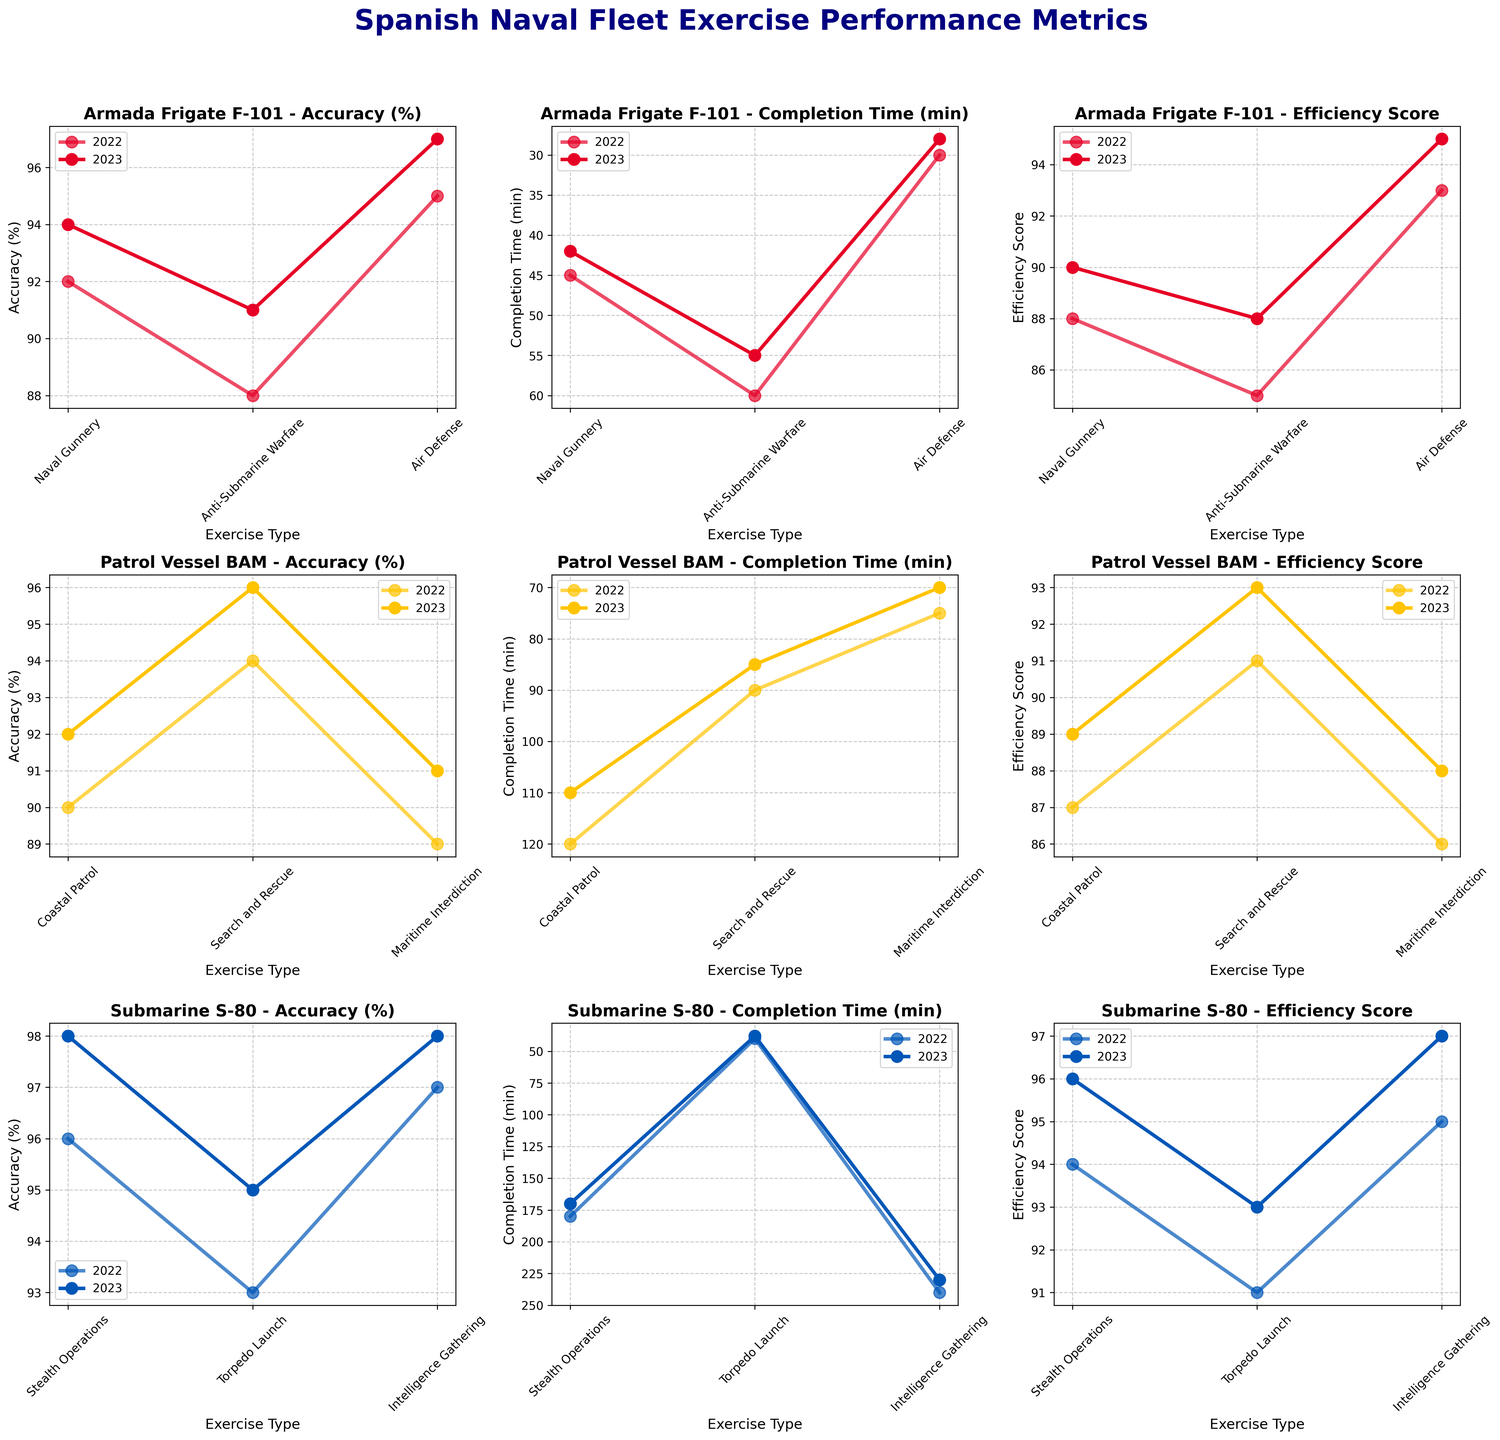What is the overall title of the figure? The figure has a main title written at the top that summarizes what the figure is displaying. This is usually the largest and boldest text.
Answer: Spanish Naval Fleet Exercise Performance Metrics Which unit performed the "Air Defense" exercise in 2023? By looking at the subplot titles and the corresponding exercise types for the year 2023, the unit can be identified. The "Air Defense" exercise type falls under the "Armada Frigate F-101" unit in 2023 as indicated on the relevant subplot.
Answer: Armada Frigate F-101 How did the "Completion Time" for the "Anti-Submarine Warfare" exercise change from 2022 to 2023 for the Armada Frigate F-101? Locate the subplot related to "Armada Frigate F-101" - "Completion Time (min)". Find the data points for "Anti-Submarine Warfare" for the years 2022 and 2023 and compare the values. The figure shows a decrease from 60 minutes in 2022 to 55 minutes in 2023.
Answer: Decreased from 60 min to 55 min Which unit and year achieved the highest Efficiency Score in "Stealth Operations"? Check each subplot for the "Stealth Operations" exercise under the "Efficiency Score" metric. Compare scores for both units and across both years. The highest score is achieved by the Submarine S-80 in 2023, which is 96.
Answer: Submarine S-80 in 2023 Compare the "Accuracy" for "Coastal Patrol" between the Patrol Vessel BAM and Submarine S-80 in 2022. Identify the subplots for "Accuracy (%)" for both units and locate the exercise type "Coastal Patrol" for 2022. The figure shows that Patrol Vessel BAM has an accuracy of 90% while Submarine S-80 does not participate in "Coastal Patrol".
Answer: Patrol Vessel BAM has 90%, Submarine S-80 did not participate Which exercise type has the maximum "Efficiency Score" for the year 2023 in Armada Frigate F-101? Within the "Armada Frigate F-101" - "Efficiency Score" subplot, examine the 2023 lines and locate the peak on the y-axis. The highest Efficiency Score is for the "Air Defense" exercise with a score of 95.
Answer: Air Defense What is the average "Accuracy" of the Submarine S-80 in 2023 across all exercise types? Sum the "Accuracy" values for Submarine S-80's exercises in 2023: (98 + 95 + 98) and divide by the number of exercises (3): (98 + 95 + 98) / 3 = 97.
Answer: 97 In which year did the Armada Frigate F-101 achieve a lower "Completion Time" for "Naval Gunnery"? Compare the "Completion Time" for the "Naval Gunnery" exercise in both years for "Armada Frigate F-101". It is 42 minutes in 2023 and 45 minutes in 2022, indicating a lower time in 2023.
Answer: 2023 